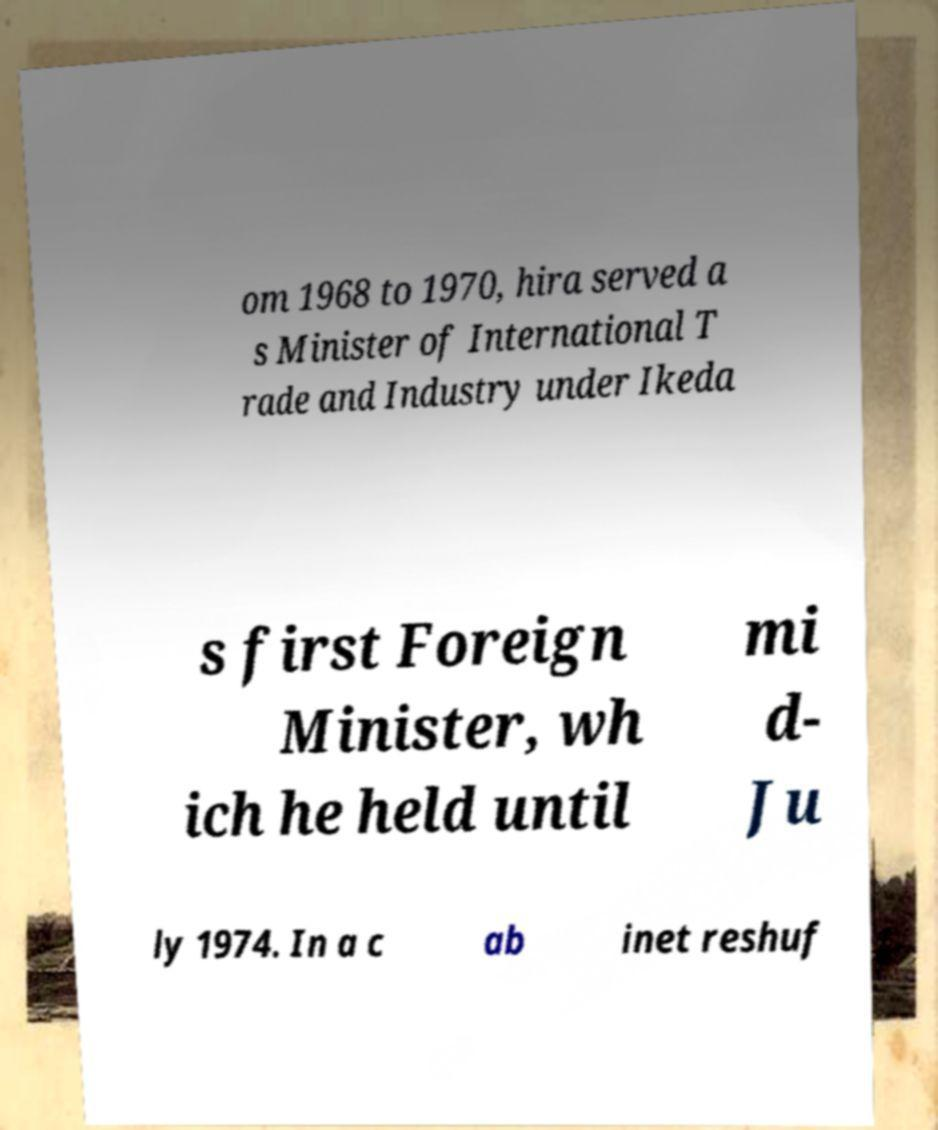There's text embedded in this image that I need extracted. Can you transcribe it verbatim? om 1968 to 1970, hira served a s Minister of International T rade and Industry under Ikeda s first Foreign Minister, wh ich he held until mi d- Ju ly 1974. In a c ab inet reshuf 